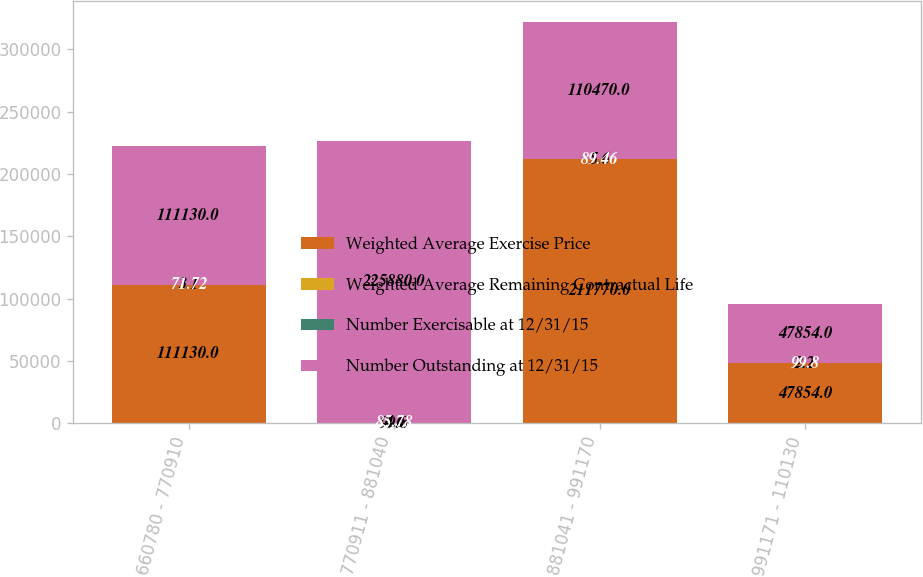<chart> <loc_0><loc_0><loc_500><loc_500><stacked_bar_chart><ecel><fcel>660780 - 770910<fcel>770911 - 881040<fcel>881041 - 991170<fcel>991171 - 110130<nl><fcel>Weighted Average Exercise Price<fcel>111130<fcel>99.8<fcel>211770<fcel>47854<nl><fcel>Weighted Average Remaining Contractual Life<fcel>3.1<fcel>4.6<fcel>5.6<fcel>2.2<nl><fcel>Number Exercisable at 12/31/15<fcel>71.72<fcel>85.78<fcel>89.46<fcel>99.8<nl><fcel>Number Outstanding at 12/31/15<fcel>111130<fcel>225880<fcel>110470<fcel>47854<nl></chart> 